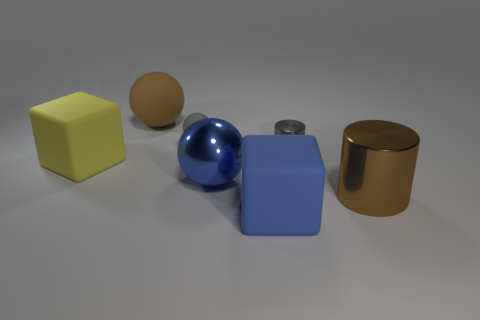What kind of materials do these objects seem to be made of? The yellow and blue cubes appear to have a matte, plastic-like finish, while the brown cylinder and the small metallic item seem to have a reflective metallic surface. The blue sphere looks to have a glossy, smooth texture, also resembling plastic. Is there anything else in the image besides these objects? No, the image focuses on these objects placed on a neutral, flat surface with no additional items or background elements. 